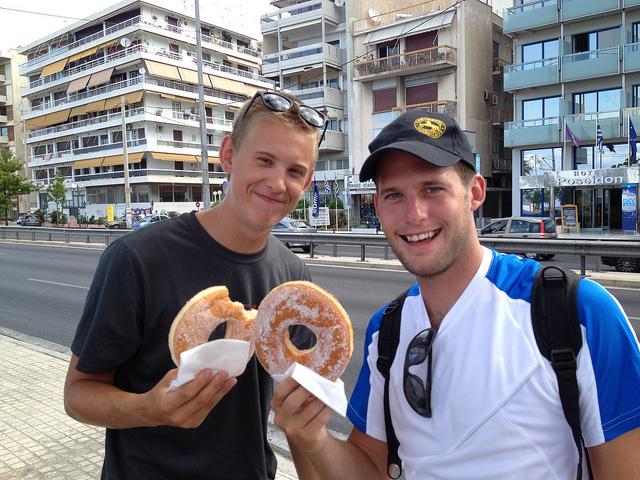What is hanging from the neck of the right man?
Give a very brief answer. Sunglasses. What are the men holding?
Keep it brief. Donuts. How many men are pictured?
Short answer required. 2. 